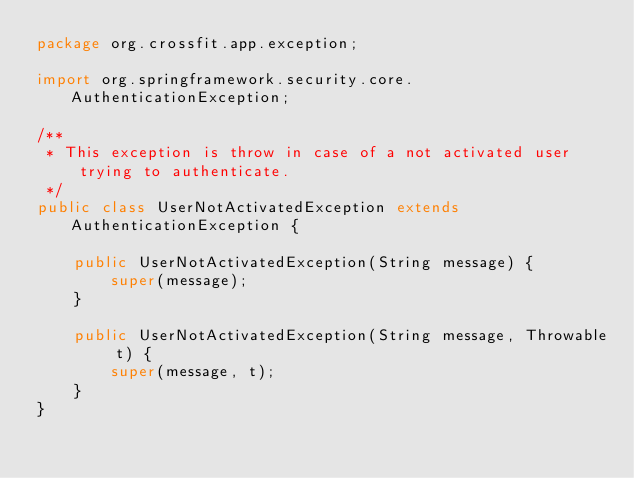<code> <loc_0><loc_0><loc_500><loc_500><_Java_>package org.crossfit.app.exception;

import org.springframework.security.core.AuthenticationException;

/**
 * This exception is throw in case of a not activated user trying to authenticate.
 */
public class UserNotActivatedException extends AuthenticationException {

    public UserNotActivatedException(String message) {
        super(message);
    }

    public UserNotActivatedException(String message, Throwable t) {
        super(message, t);
    }
}
</code> 